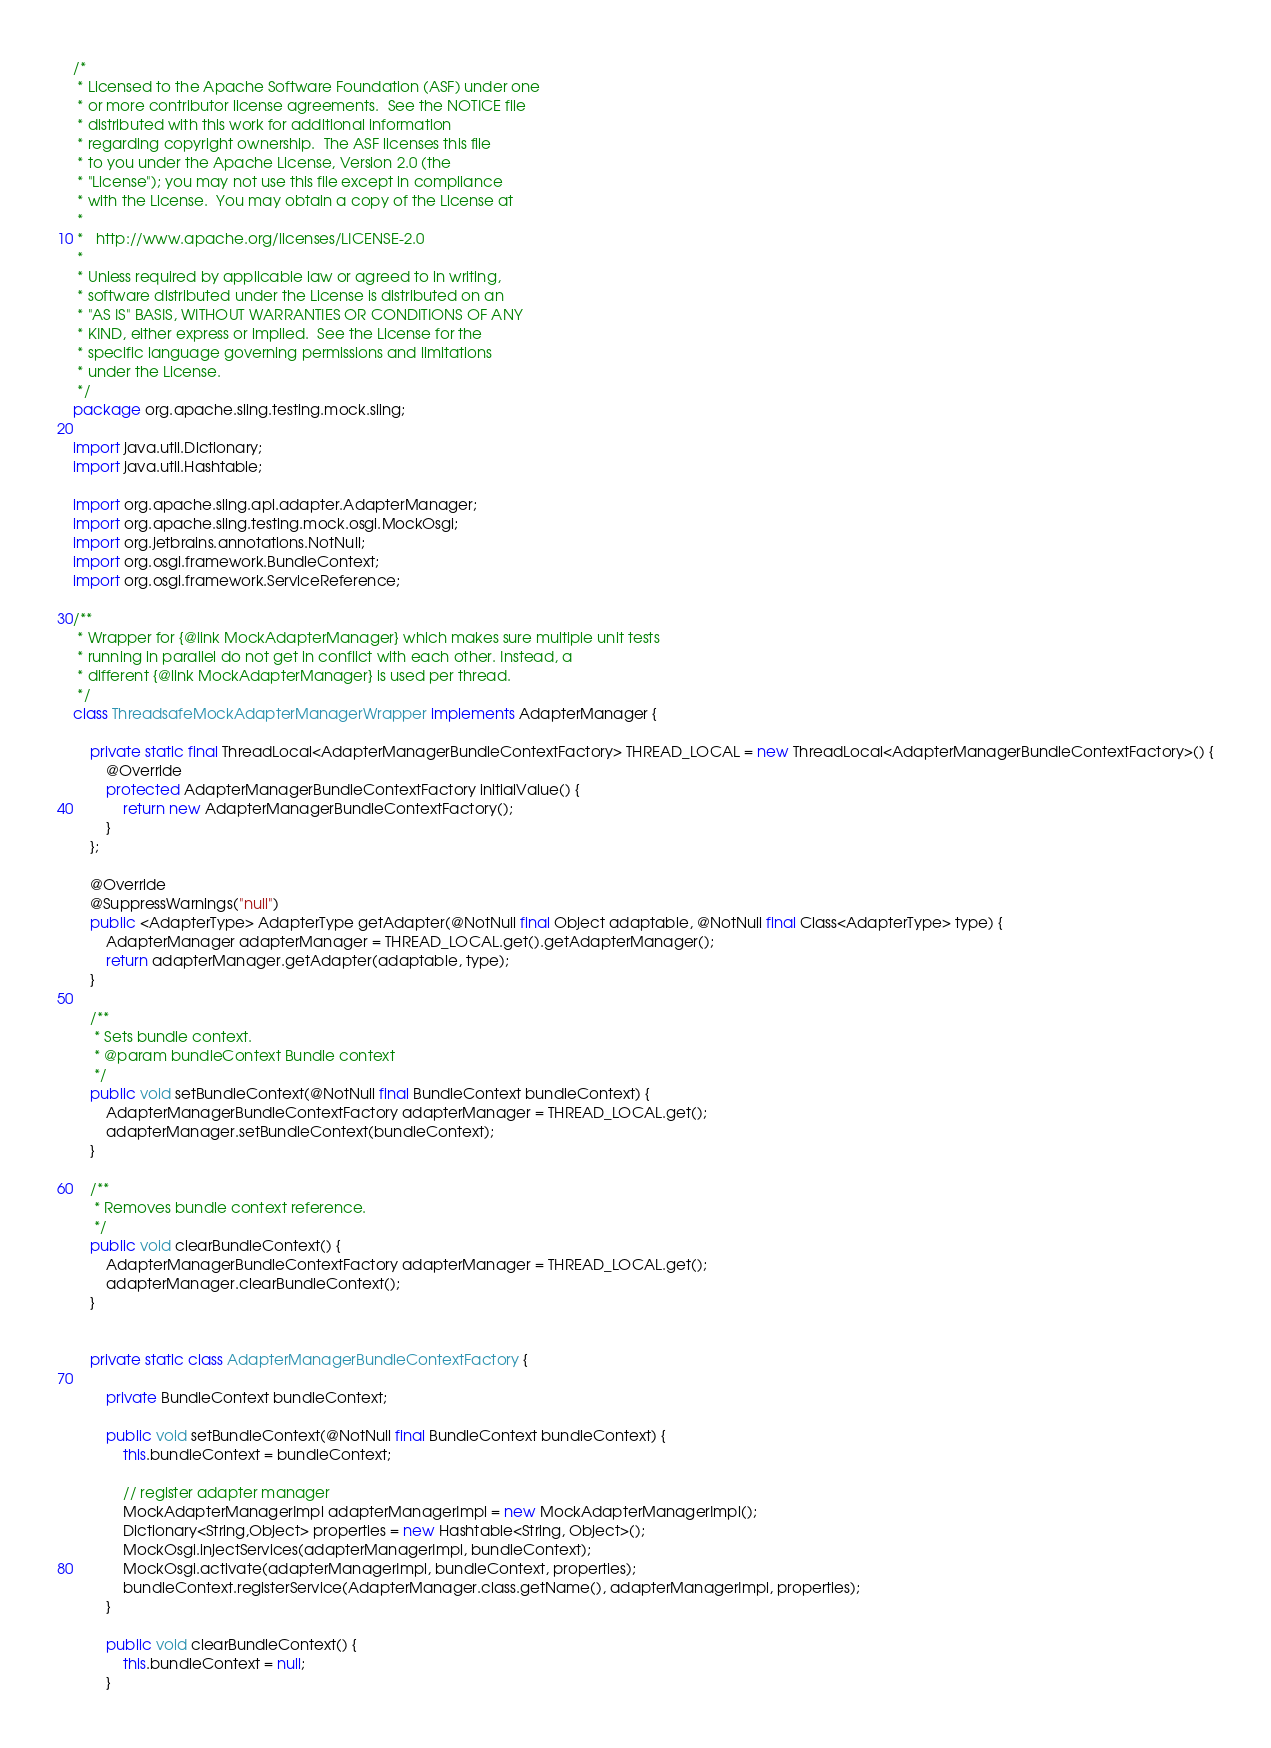<code> <loc_0><loc_0><loc_500><loc_500><_Java_>/*
 * Licensed to the Apache Software Foundation (ASF) under one
 * or more contributor license agreements.  See the NOTICE file
 * distributed with this work for additional information
 * regarding copyright ownership.  The ASF licenses this file
 * to you under the Apache License, Version 2.0 (the
 * "License"); you may not use this file except in compliance
 * with the License.  You may obtain a copy of the License at
 *
 *   http://www.apache.org/licenses/LICENSE-2.0
 *
 * Unless required by applicable law or agreed to in writing,
 * software distributed under the License is distributed on an
 * "AS IS" BASIS, WITHOUT WARRANTIES OR CONDITIONS OF ANY
 * KIND, either express or implied.  See the License for the
 * specific language governing permissions and limitations
 * under the License.
 */
package org.apache.sling.testing.mock.sling;

import java.util.Dictionary;
import java.util.Hashtable;

import org.apache.sling.api.adapter.AdapterManager;
import org.apache.sling.testing.mock.osgi.MockOsgi;
import org.jetbrains.annotations.NotNull;
import org.osgi.framework.BundleContext;
import org.osgi.framework.ServiceReference;

/**
 * Wrapper for {@link MockAdapterManager} which makes sure multiple unit tests
 * running in parallel do not get in conflict with each other. Instead, a
 * different {@link MockAdapterManager} is used per thread.
 */
class ThreadsafeMockAdapterManagerWrapper implements AdapterManager {

    private static final ThreadLocal<AdapterManagerBundleContextFactory> THREAD_LOCAL = new ThreadLocal<AdapterManagerBundleContextFactory>() {
        @Override
        protected AdapterManagerBundleContextFactory initialValue() {
            return new AdapterManagerBundleContextFactory();
        }
    };

    @Override
    @SuppressWarnings("null")
    public <AdapterType> AdapterType getAdapter(@NotNull final Object adaptable, @NotNull final Class<AdapterType> type) {
        AdapterManager adapterManager = THREAD_LOCAL.get().getAdapterManager();
        return adapterManager.getAdapter(adaptable, type);
    }

    /**
     * Sets bundle context.
     * @param bundleContext Bundle context
     */
    public void setBundleContext(@NotNull final BundleContext bundleContext) {
        AdapterManagerBundleContextFactory adapterManager = THREAD_LOCAL.get();
        adapterManager.setBundleContext(bundleContext);
    }

    /**
     * Removes bundle context reference.
     */
    public void clearBundleContext() {
        AdapterManagerBundleContextFactory adapterManager = THREAD_LOCAL.get();
        adapterManager.clearBundleContext();
    }


    private static class AdapterManagerBundleContextFactory {

        private BundleContext bundleContext;

        public void setBundleContext(@NotNull final BundleContext bundleContext) {
            this.bundleContext = bundleContext;

            // register adapter manager
            MockAdapterManagerImpl adapterManagerImpl = new MockAdapterManagerImpl();
            Dictionary<String,Object> properties = new Hashtable<String, Object>();
            MockOsgi.injectServices(adapterManagerImpl, bundleContext);
            MockOsgi.activate(adapterManagerImpl, bundleContext, properties);
            bundleContext.registerService(AdapterManager.class.getName(), adapterManagerImpl, properties);
        }

        public void clearBundleContext() {
            this.bundleContext = null;
        }
</code> 